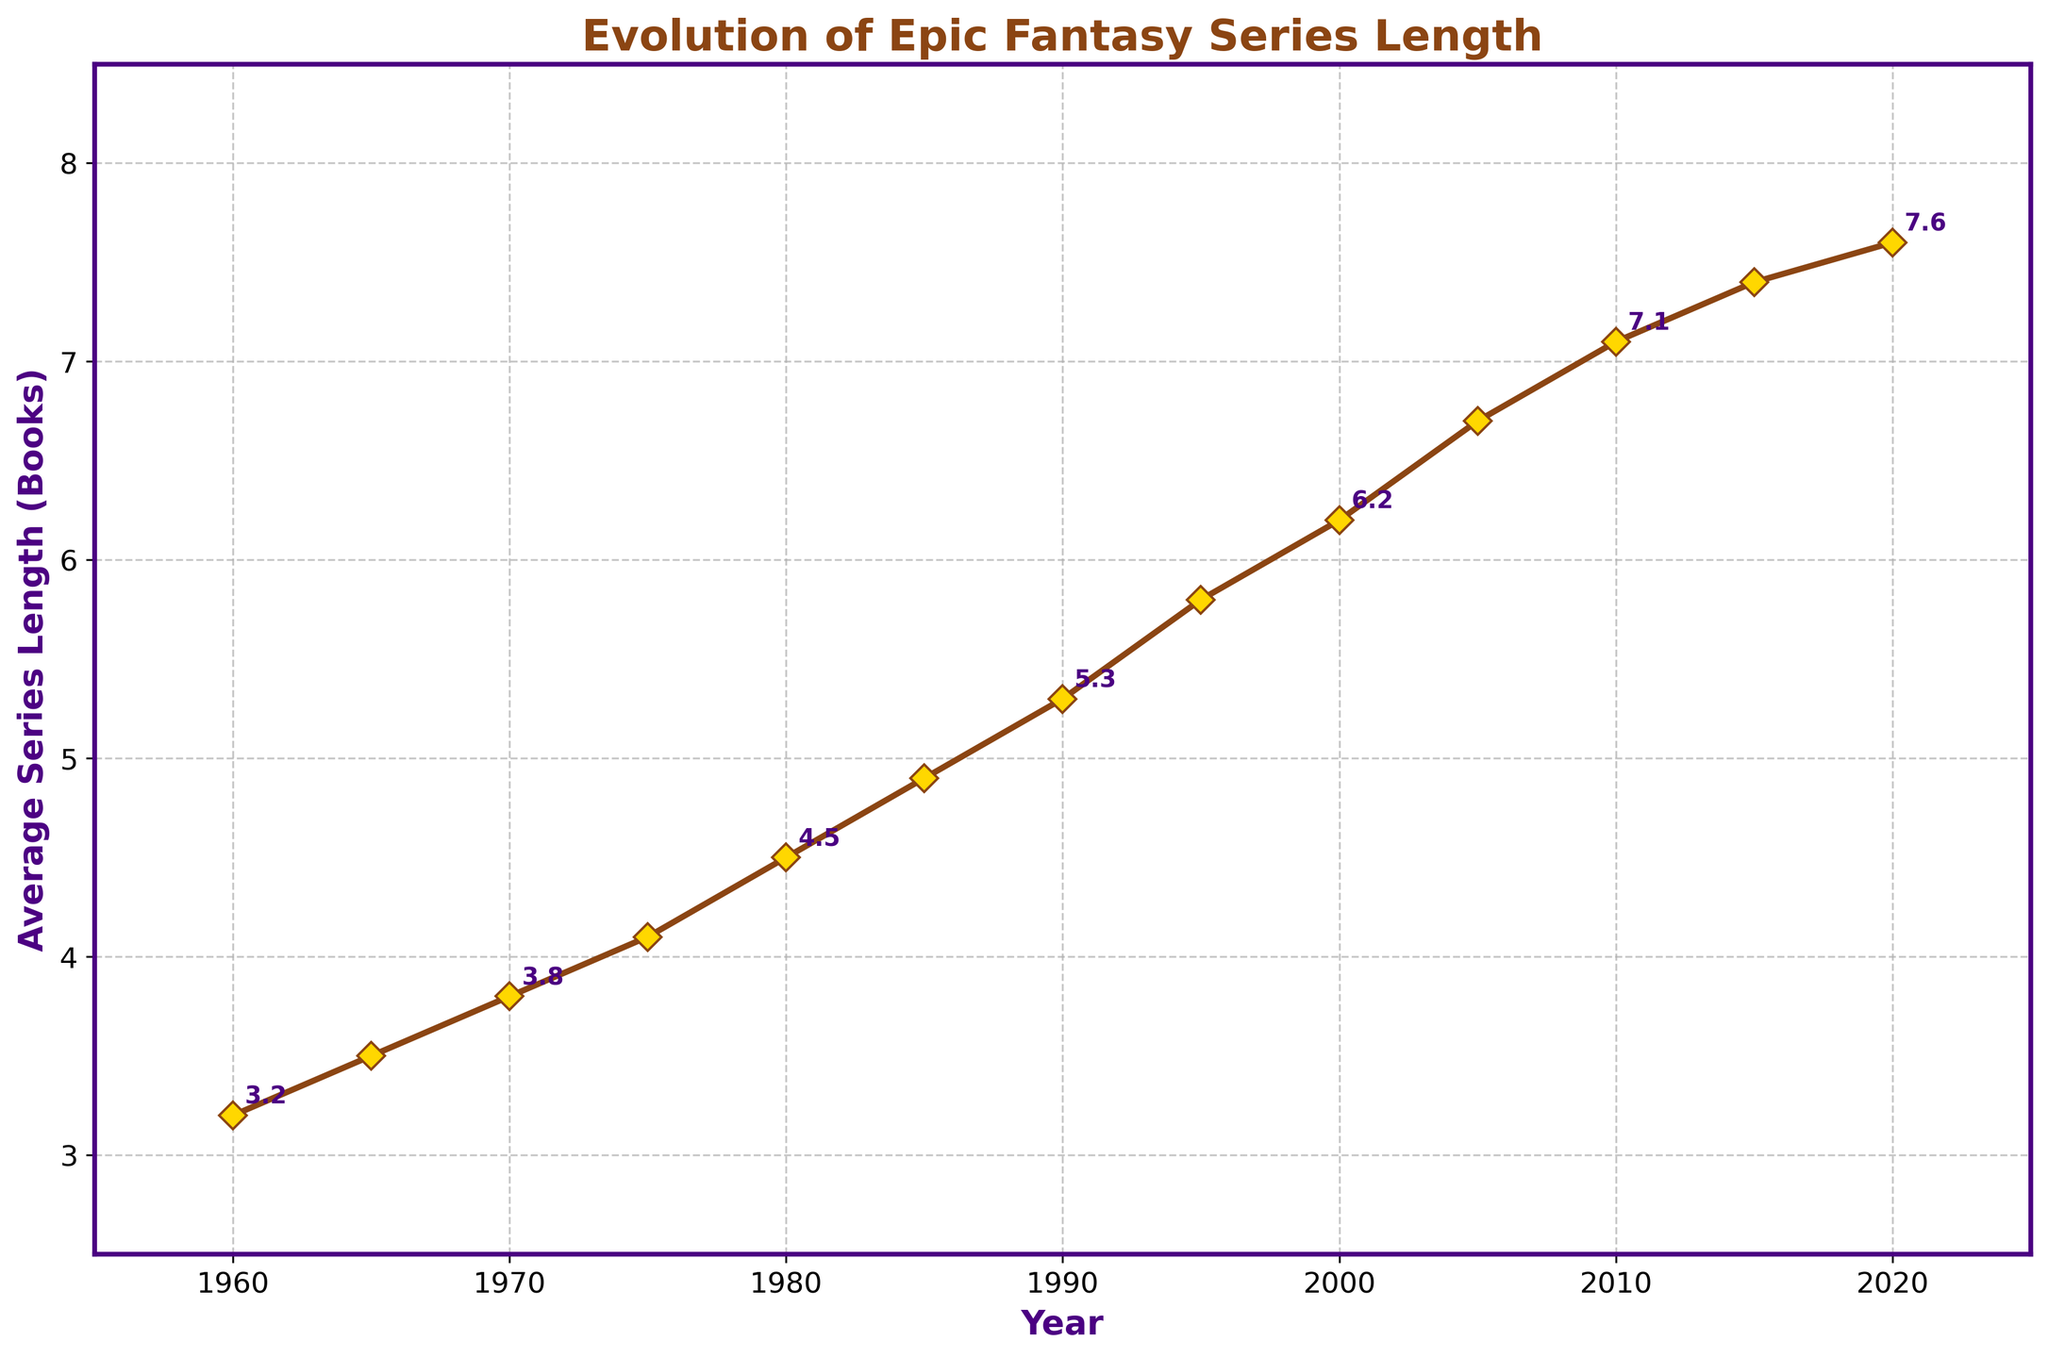What is the average series length in 1990? The plot indicates that the average series length in 1990 is marked, and we can directly read it from the graph.
Answer: 5.3 How many books did the average series length increase by from 1975 to 2000? To find the increase, subtract the average series length in 1975 from that in 2000. From the plot, the lengths are 4.1 in 1975 and 6.2 in 2000. The increase is 6.2 - 4.1.
Answer: 2.1 Which year had a greater average series length, 1980 or 1970? Compare the two points on the graph for the years 1980 and 1970. The average length in 1980 is 4.5, while in 1970 it is 3.8. Hence, 1980 had a greater length.
Answer: 1980 What is the overall trend in the average series length from 1960 to 2020? Observing the whole line chart from 1960 to 2020 shows a steady upward trend in the average series length.
Answer: Increasing trend How often is the value annotated on the graph, and what is the annotation value for 1975? Annotations are displayed every other year, and for the year 1975, the annotation value is noted right next to the point marked on the graph. The annotation for 1975 reads 4.1.
Answer: 4.1 In which decade did the average series length first exceed 5 books? To determine this, find the first point on the graph where the length exceeds 5, which occurs in 1985.
Answer: 1980s Compare the average series length in 2010 and 2015. Which year had a higher average, and by how much? From the graph, the lengths are 7.1 in 2010 and 7.4 in 2015. To find the difference, subtract 7.1 from 7.4.
Answer: 2015 by 0.3 What does the marker color and shape signify on the graph? The markers are yellow diamonds with brown borders, used to highlight data points. This distinct color and shape help in clearly identifying the data points on the line.
Answer: Yellow diamonds with brown borders What is the difference in average series length between 1960 and 2020? Subtract the average series length in 1960 from that in 2020. From the graph, the length in 1960 is 3.2 and in 2020 is 7.6. The difference is 7.6 - 3.2.
Answer: 4.4 